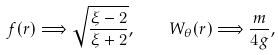Convert formula to latex. <formula><loc_0><loc_0><loc_500><loc_500>f ( r ) \Longrightarrow \sqrt { \frac { \xi - 2 } { \xi + 2 } } , \quad W _ { \theta } ( r ) \Longrightarrow \frac { m } { 4 g } ,</formula> 